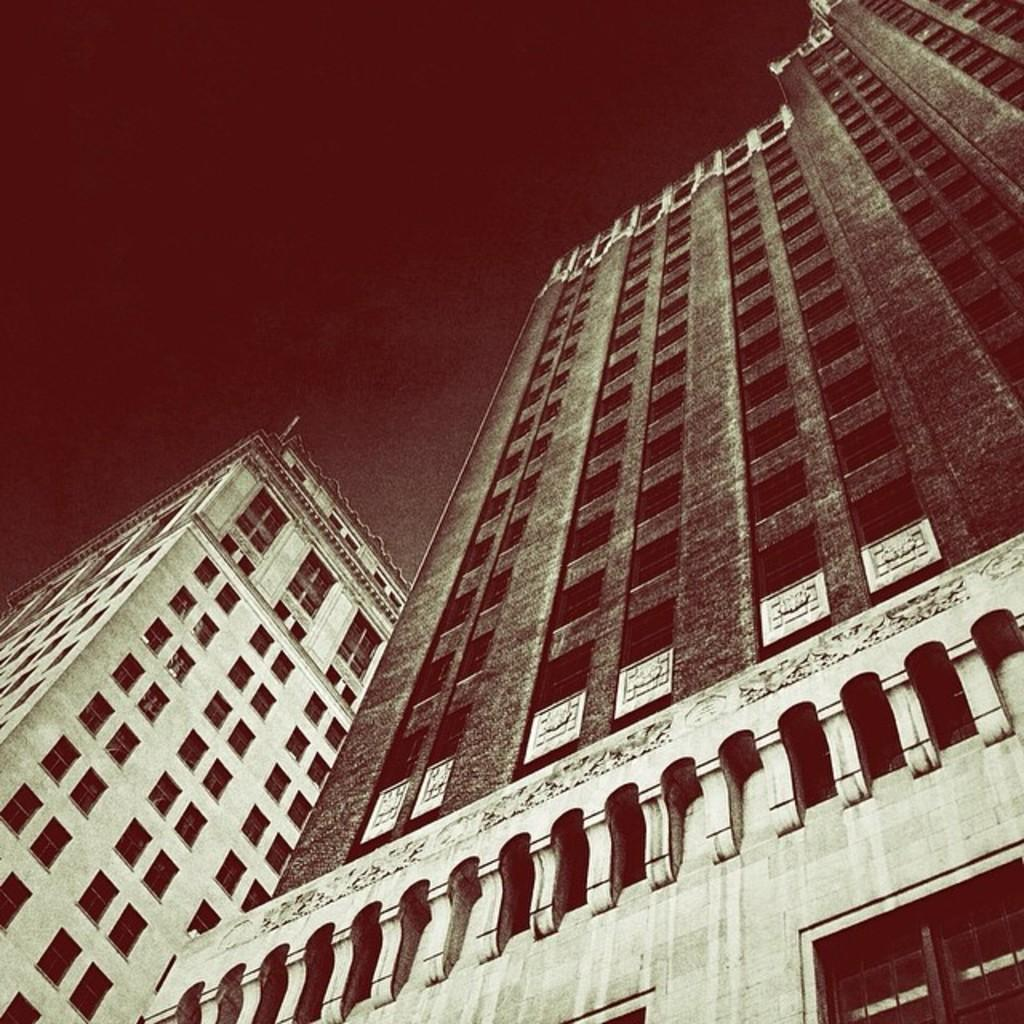What type of structures can be seen in the image? There are buildings in the image. What feature do the buildings have in common? The buildings have windows. What type of vacation is being advertised on the buildings in the image? There is no indication of a vacation being advertised on the buildings in the image. What song is being played by the buildings in the image? Buildings do not play songs; they are inanimate structures. 